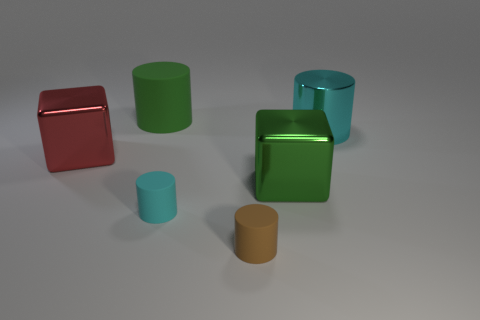Add 2 big green objects. How many objects exist? 8 Subtract all blocks. How many objects are left? 4 Subtract all purple metal blocks. Subtract all big red shiny things. How many objects are left? 5 Add 6 large green matte cylinders. How many large green matte cylinders are left? 7 Add 2 small gray things. How many small gray things exist? 2 Subtract 0 purple spheres. How many objects are left? 6 